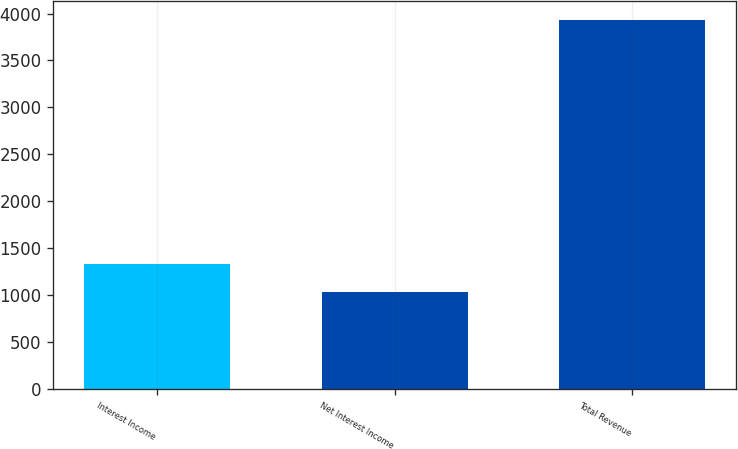Convert chart to OTSL. <chart><loc_0><loc_0><loc_500><loc_500><bar_chart><fcel>Interest Income<fcel>Net Interest Income<fcel>Total Revenue<nl><fcel>1328.5<fcel>1031.1<fcel>3936.9<nl></chart> 